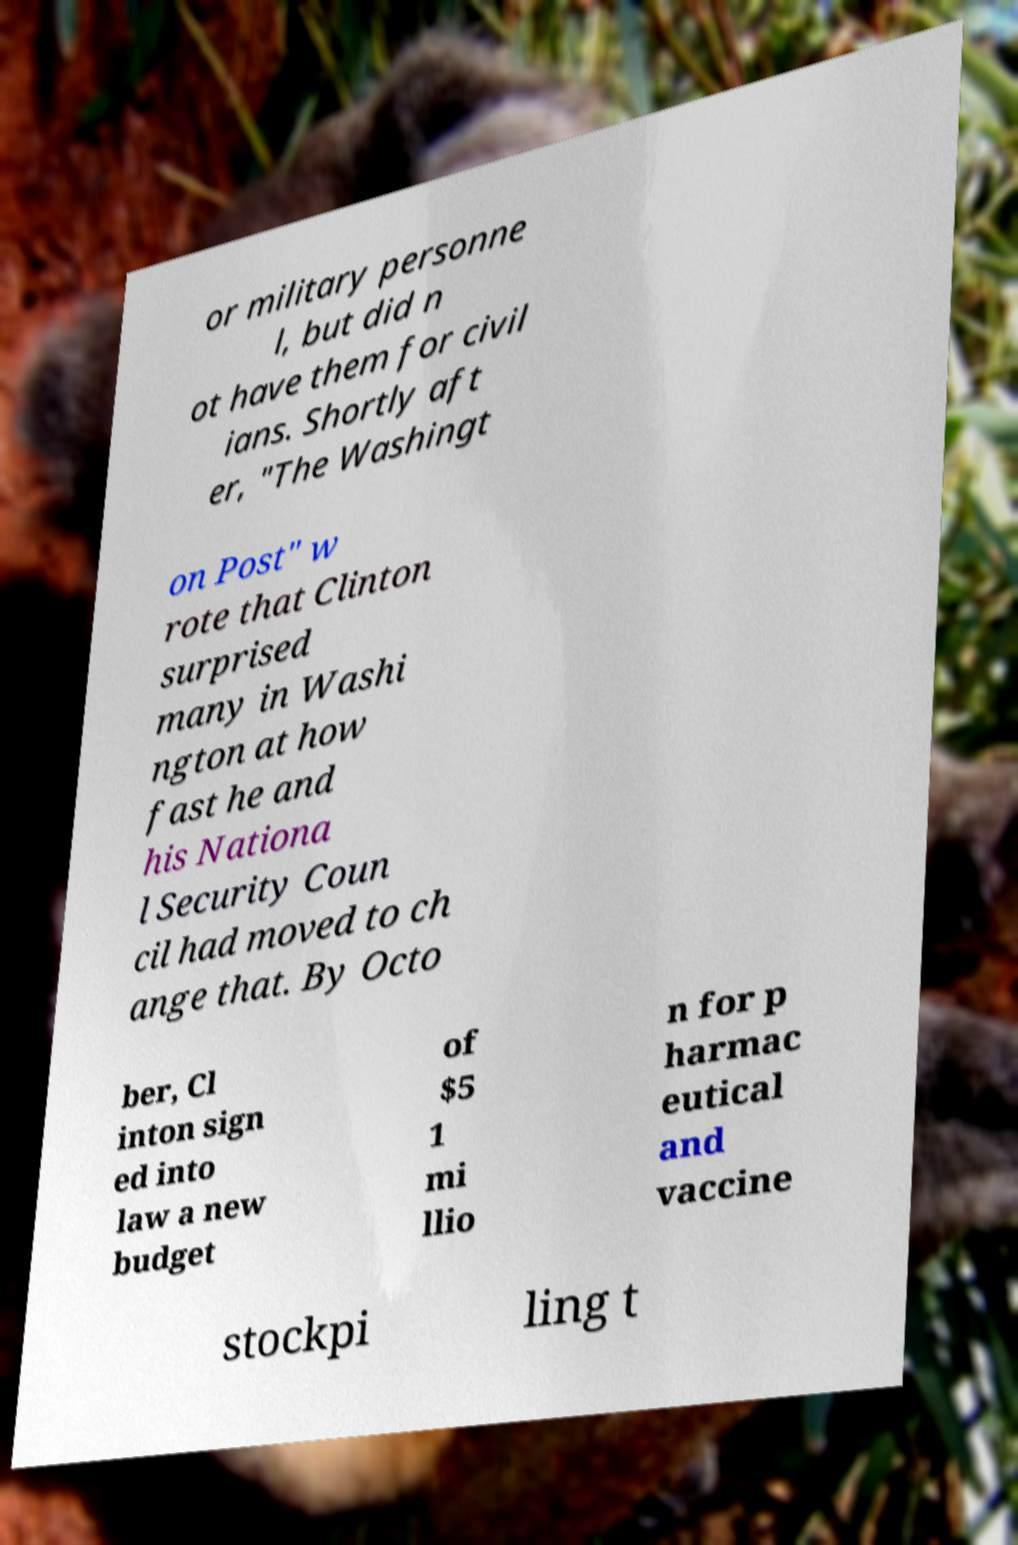For documentation purposes, I need the text within this image transcribed. Could you provide that? or military personne l, but did n ot have them for civil ians. Shortly aft er, "The Washingt on Post" w rote that Clinton surprised many in Washi ngton at how fast he and his Nationa l Security Coun cil had moved to ch ange that. By Octo ber, Cl inton sign ed into law a new budget of $5 1 mi llio n for p harmac eutical and vaccine stockpi ling t 